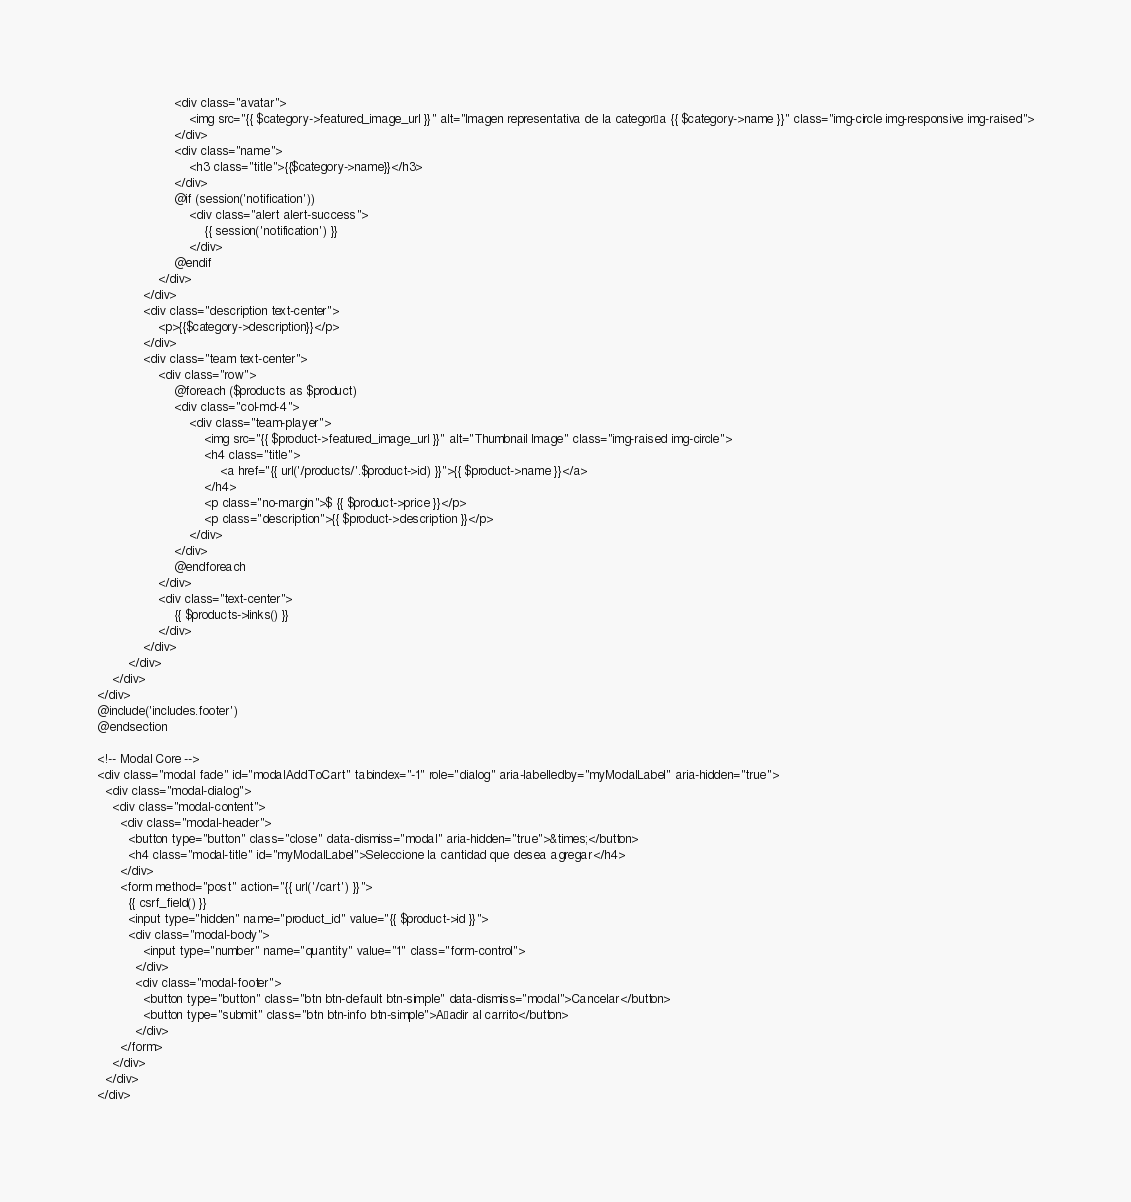<code> <loc_0><loc_0><loc_500><loc_500><_PHP_>                    <div class="avatar">
                        <img src="{{ $category->featured_image_url }}" alt="Imagen representativa de la categoría {{ $category->name }}" class="img-circle img-responsive img-raised">
                    </div>
                    <div class="name">
                        <h3 class="title">{{$category->name}}</h3>
                    </div>
                    @if (session('notification'))
                        <div class="alert alert-success">
                            {{ session('notification') }}
                        </div>
                    @endif                    
                </div>
            </div>
            <div class="description text-center">
                <p>{{$category->description}}</p>
            </div>
            <div class="team text-center">
                <div class="row">
                    @foreach ($products as $product)
                    <div class="col-md-4">
                        <div class="team-player">
                            <img src="{{ $product->featured_image_url }}" alt="Thumbnail Image" class="img-raised img-circle">
                            <h4 class="title">
                                <a href="{{ url('/products/'.$product->id) }}">{{ $product->name }}</a>
                            </h4>
                            <p class="no-margin">$ {{ $product->price }}</p>
                            <p class="description">{{ $product->description }}</p>
                        </div>
                    </div>
                    @endforeach
                </div>
                <div class="text-center">
                    {{ $products->links() }}
                </div>
            </div>
        </div>
    </div>
</div>
@include('includes.footer')
@endsection

<!-- Modal Core -->
<div class="modal fade" id="modalAddToCart" tabindex="-1" role="dialog" aria-labelledby="myModalLabel" aria-hidden="true">
  <div class="modal-dialog">
    <div class="modal-content">
      <div class="modal-header">
        <button type="button" class="close" data-dismiss="modal" aria-hidden="true">&times;</button>
        <h4 class="modal-title" id="myModalLabel">Seleccione la cantidad que desea agregar</h4>
      </div>
      <form method="post" action="{{ url('/cart') }}">
        {{ csrf_field() }}
        <input type="hidden" name="product_id" value="{{ $product->id }}">
        <div class="modal-body">
            <input type="number" name="quantity" value="1" class="form-control">
          </div>
          <div class="modal-footer">
            <button type="button" class="btn btn-default btn-simple" data-dismiss="modal">Cancelar</button>
            <button type="submit" class="btn btn-info btn-simple">Añadir al carrito</button>
          </div>
      </form>
    </div>
  </div>
</div>  </code> 